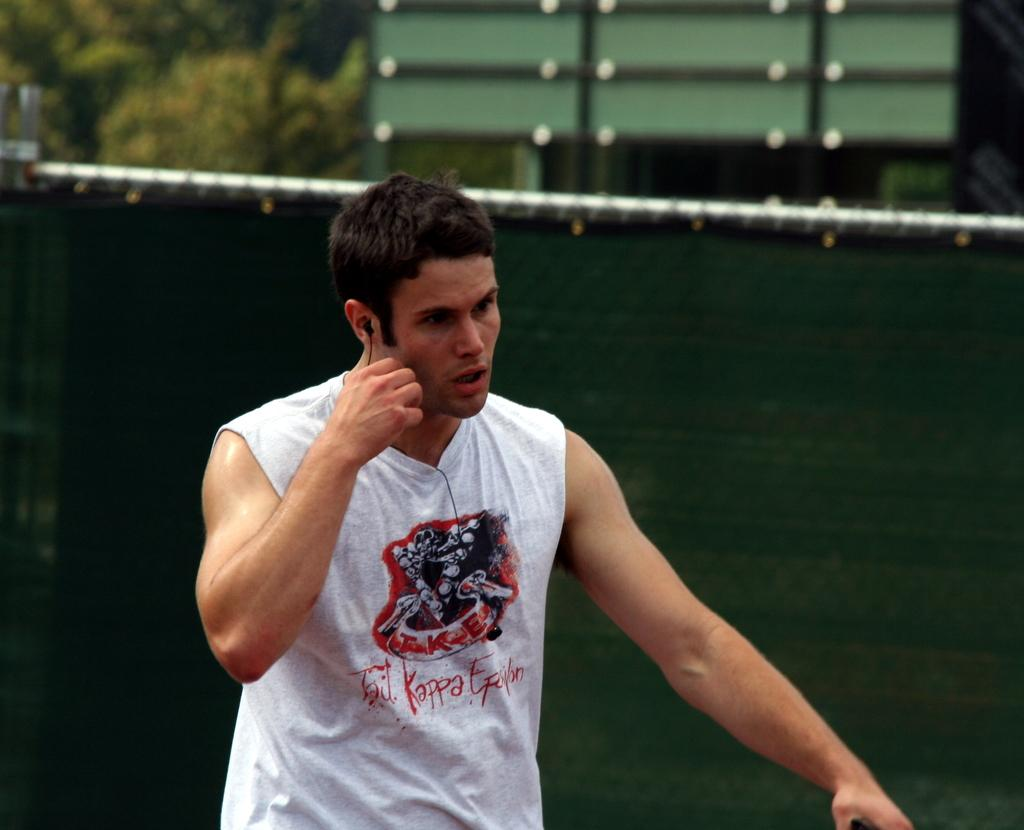<image>
Relay a brief, clear account of the picture shown. a guy on a cell phone wearing tko tail kappa epsilon tanktop 